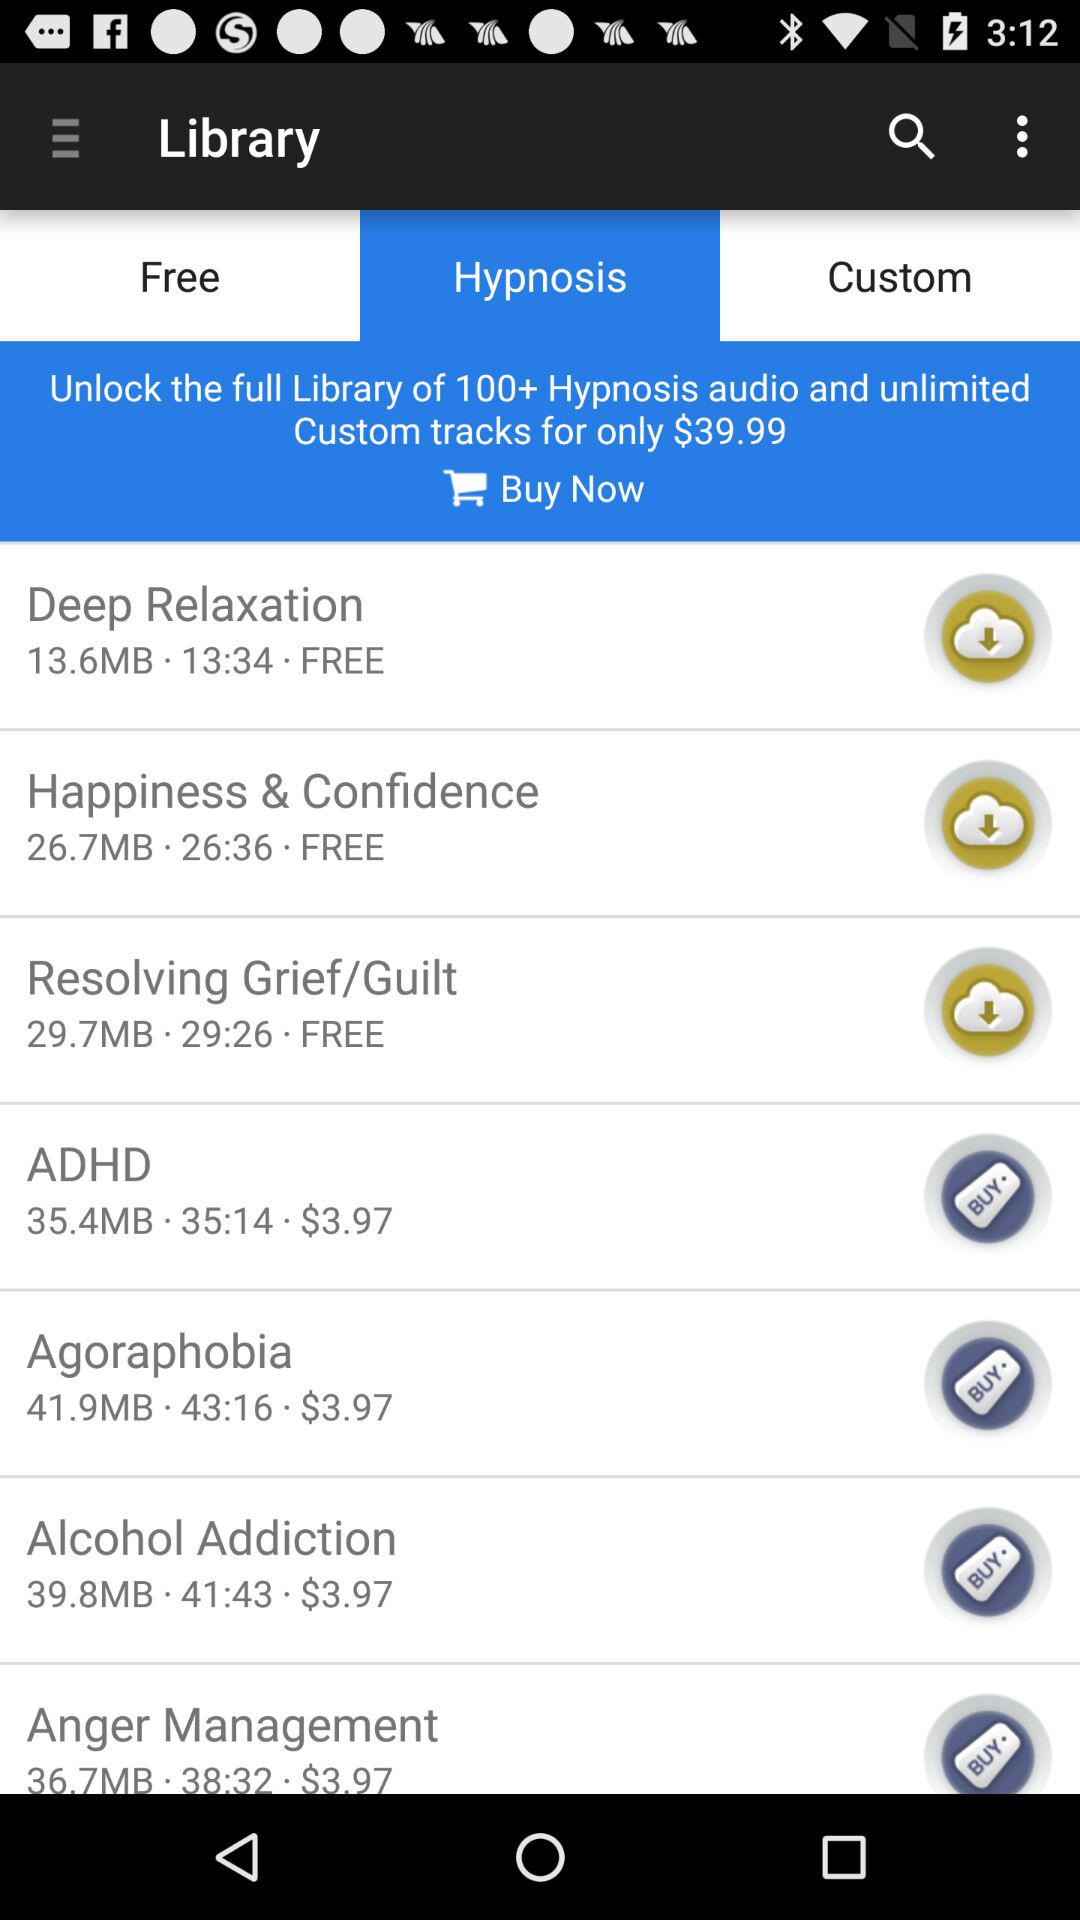How many hypnosis tracks are free?
Answer the question using a single word or phrase. 3 